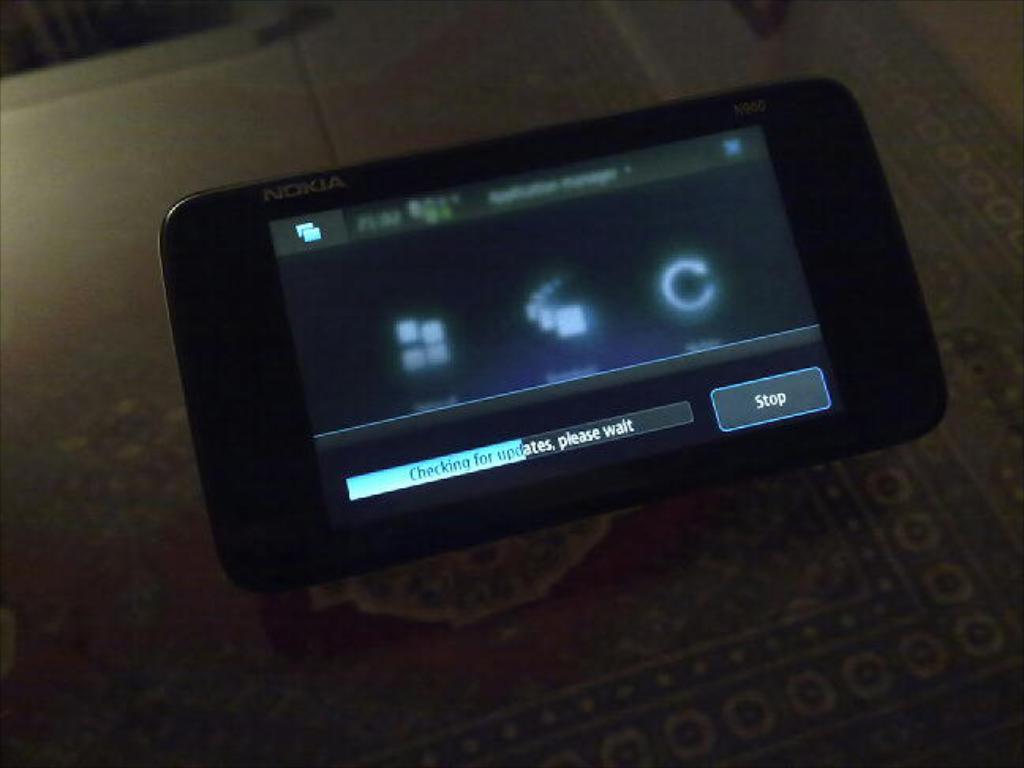What brand of device is this?
Give a very brief answer. Nokia. What does the right box say?
Offer a terse response. Stop. 